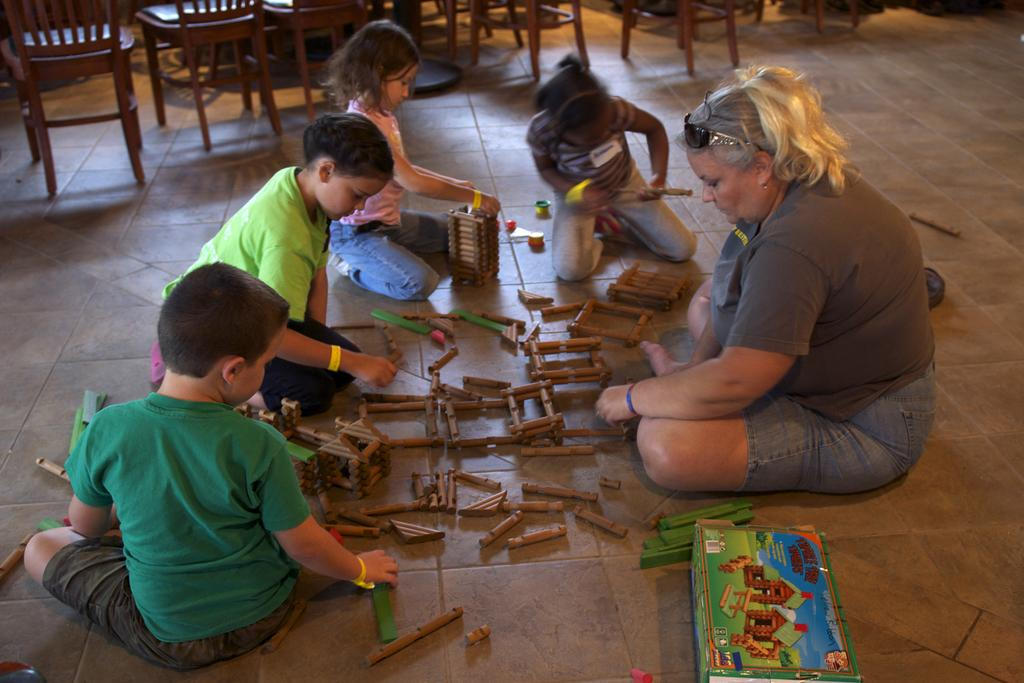What are the people in the image doing? The people in the image are sitting on the floor and playing a game. What objects are involved in the game? There are toys involved in the game. What can be seen in the background of the image? There are chairs visible in the background of the image. Is there any chalk being used to make payments during the game in the image? There is no chalk or payment-related activity present in the image; the people are simply playing a game with toys. 